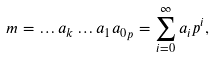Convert formula to latex. <formula><loc_0><loc_0><loc_500><loc_500>m = { \dots a _ { k } \dots a _ { 1 } a _ { 0 } } _ { p } = \sum _ { i = 0 } ^ { \infty } a _ { i } p ^ { i } ,</formula> 